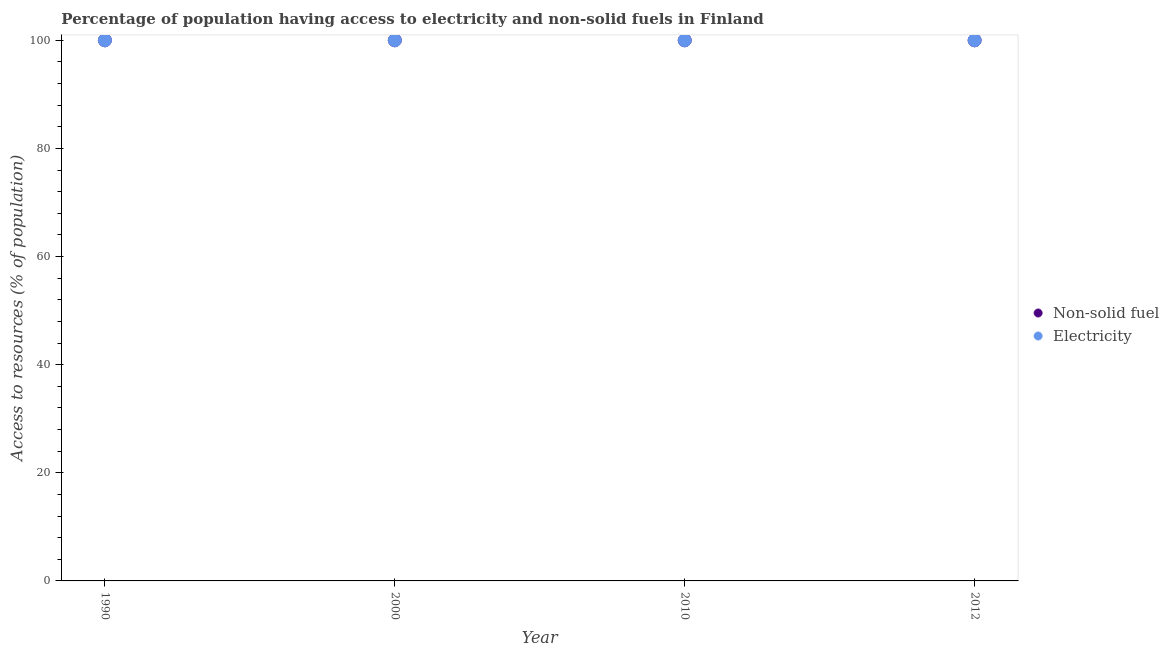How many different coloured dotlines are there?
Your answer should be very brief. 2. What is the percentage of population having access to non-solid fuel in 1990?
Keep it short and to the point. 100. Across all years, what is the maximum percentage of population having access to electricity?
Offer a terse response. 100. Across all years, what is the minimum percentage of population having access to non-solid fuel?
Your answer should be very brief. 100. In which year was the percentage of population having access to non-solid fuel minimum?
Keep it short and to the point. 1990. What is the total percentage of population having access to non-solid fuel in the graph?
Provide a succinct answer. 400. What is the difference between the percentage of population having access to electricity in 2010 and the percentage of population having access to non-solid fuel in 2000?
Offer a very short reply. 0. What is the average percentage of population having access to non-solid fuel per year?
Offer a very short reply. 100. In how many years, is the percentage of population having access to electricity greater than 24 %?
Make the answer very short. 4. Is the percentage of population having access to electricity in 1990 less than that in 2012?
Keep it short and to the point. No. Is the difference between the percentage of population having access to non-solid fuel in 2000 and 2010 greater than the difference between the percentage of population having access to electricity in 2000 and 2010?
Your response must be concise. No. What is the difference between the highest and the second highest percentage of population having access to electricity?
Make the answer very short. 0. What is the difference between the highest and the lowest percentage of population having access to non-solid fuel?
Your answer should be very brief. 0. In how many years, is the percentage of population having access to electricity greater than the average percentage of population having access to electricity taken over all years?
Offer a very short reply. 0. Does the percentage of population having access to non-solid fuel monotonically increase over the years?
Provide a short and direct response. No. Is the percentage of population having access to non-solid fuel strictly greater than the percentage of population having access to electricity over the years?
Ensure brevity in your answer.  No. Are the values on the major ticks of Y-axis written in scientific E-notation?
Provide a succinct answer. No. Does the graph contain any zero values?
Provide a short and direct response. No. Where does the legend appear in the graph?
Offer a terse response. Center right. What is the title of the graph?
Your answer should be very brief. Percentage of population having access to electricity and non-solid fuels in Finland. What is the label or title of the X-axis?
Ensure brevity in your answer.  Year. What is the label or title of the Y-axis?
Provide a succinct answer. Access to resources (% of population). What is the Access to resources (% of population) of Electricity in 1990?
Offer a very short reply. 100. What is the Access to resources (% of population) in Non-solid fuel in 2000?
Your answer should be compact. 100. What is the Access to resources (% of population) in Electricity in 2000?
Provide a short and direct response. 100. What is the Access to resources (% of population) of Non-solid fuel in 2010?
Give a very brief answer. 100. What is the Access to resources (% of population) of Electricity in 2012?
Your answer should be very brief. 100. Across all years, what is the minimum Access to resources (% of population) of Non-solid fuel?
Your answer should be compact. 100. Across all years, what is the minimum Access to resources (% of population) in Electricity?
Keep it short and to the point. 100. What is the total Access to resources (% of population) of Non-solid fuel in the graph?
Ensure brevity in your answer.  400. What is the total Access to resources (% of population) in Electricity in the graph?
Ensure brevity in your answer.  400. What is the difference between the Access to resources (% of population) in Non-solid fuel in 1990 and that in 2010?
Offer a terse response. 0. What is the difference between the Access to resources (% of population) of Non-solid fuel in 1990 and that in 2012?
Ensure brevity in your answer.  0. What is the difference between the Access to resources (% of population) in Electricity in 1990 and that in 2012?
Keep it short and to the point. 0. What is the difference between the Access to resources (% of population) of Non-solid fuel in 1990 and the Access to resources (% of population) of Electricity in 2010?
Your answer should be very brief. 0. What is the difference between the Access to resources (% of population) of Non-solid fuel in 1990 and the Access to resources (% of population) of Electricity in 2012?
Provide a short and direct response. 0. What is the average Access to resources (% of population) in Non-solid fuel per year?
Your answer should be compact. 100. In the year 1990, what is the difference between the Access to resources (% of population) of Non-solid fuel and Access to resources (% of population) of Electricity?
Your answer should be compact. 0. What is the ratio of the Access to resources (% of population) in Non-solid fuel in 1990 to that in 2010?
Your answer should be very brief. 1. What is the ratio of the Access to resources (% of population) in Non-solid fuel in 2000 to that in 2010?
Keep it short and to the point. 1. What is the ratio of the Access to resources (% of population) in Electricity in 2000 to that in 2010?
Give a very brief answer. 1. What is the ratio of the Access to resources (% of population) of Non-solid fuel in 2000 to that in 2012?
Provide a succinct answer. 1. What is the ratio of the Access to resources (% of population) in Electricity in 2000 to that in 2012?
Keep it short and to the point. 1. What is the difference between the highest and the second highest Access to resources (% of population) of Non-solid fuel?
Keep it short and to the point. 0. What is the difference between the highest and the second highest Access to resources (% of population) in Electricity?
Provide a succinct answer. 0. What is the difference between the highest and the lowest Access to resources (% of population) of Non-solid fuel?
Provide a succinct answer. 0. What is the difference between the highest and the lowest Access to resources (% of population) of Electricity?
Keep it short and to the point. 0. 